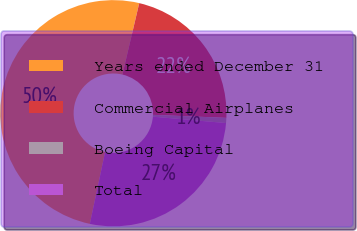Convert chart. <chart><loc_0><loc_0><loc_500><loc_500><pie_chart><fcel>Years ended December 31<fcel>Commercial Airplanes<fcel>Boeing Capital<fcel>Total<nl><fcel>50.35%<fcel>21.98%<fcel>0.73%<fcel>26.95%<nl></chart> 